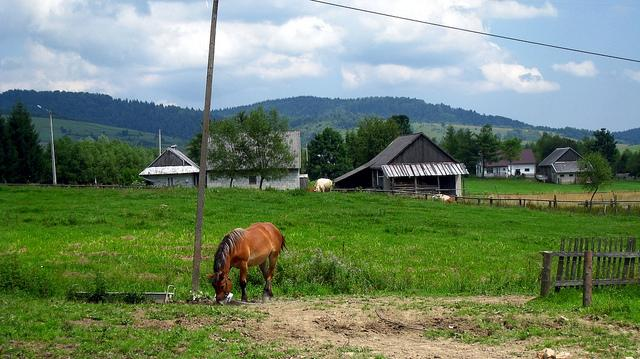What is the large pole near the horse supplying to the homes? electricity 